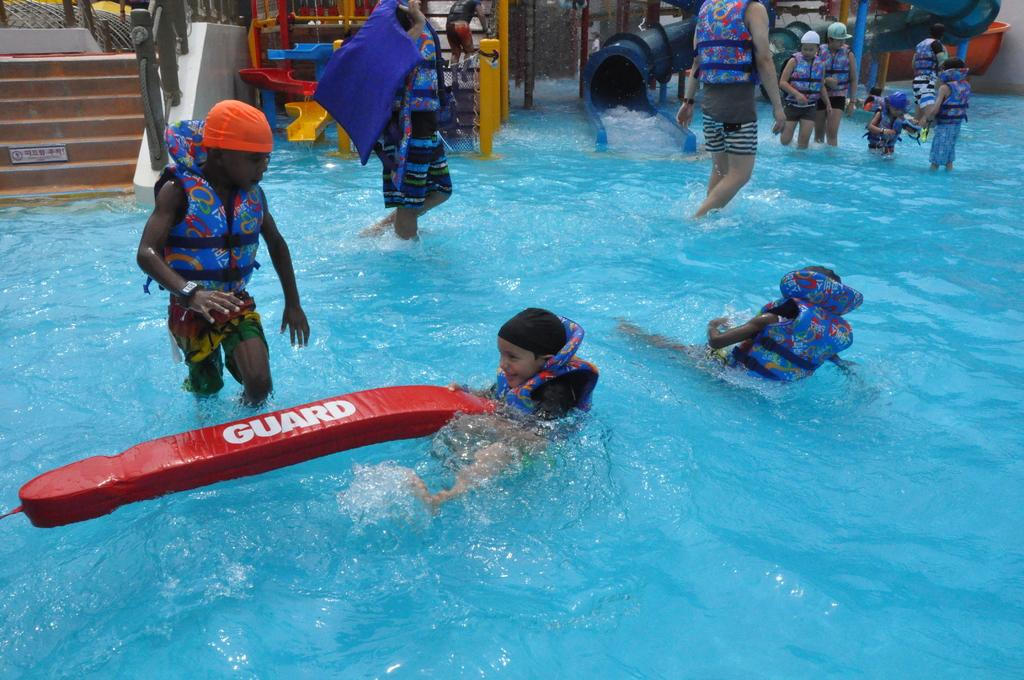What are the people in the image doing? The people in the image are in the water. What safety precautions are the people taking? The people are wearing life jackets. What can be seen in the background of the image? There are water slides and steps in the background. What is the boy holding in the image? The boy is holding a water object. How much money is the boy holding in the image? The boy is not holding any money in the image; he is holding a water object. Can you tell me what book the people are reading while in the water? There is no book present in the image; the people are in the water without any visible reading material. 